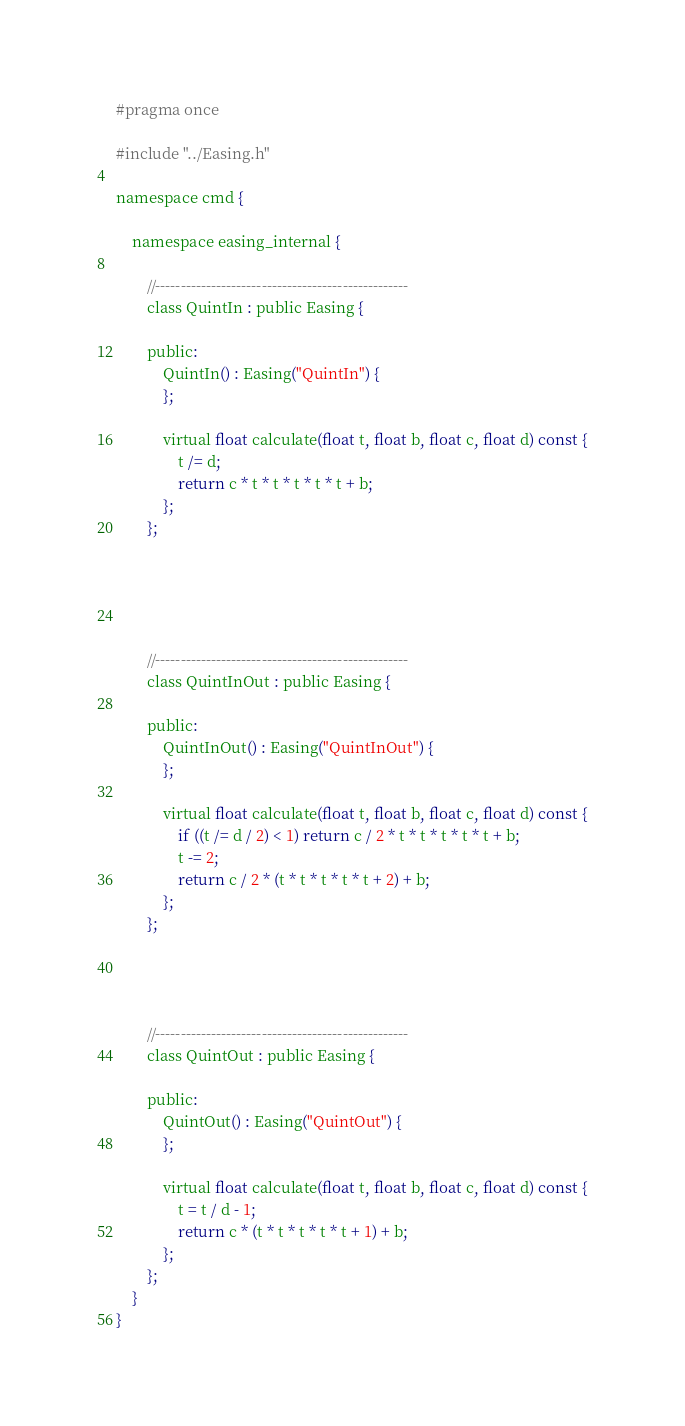Convert code to text. <code><loc_0><loc_0><loc_500><loc_500><_C_>#pragma once

#include "../Easing.h"

namespace cmd {

	namespace easing_internal {

		//--------------------------------------------------
		class QuintIn : public Easing {

		public:
			QuintIn() : Easing("QuintIn") {
			};

			virtual float calculate(float t, float b, float c, float d) const {
				t /= d;
				return c * t * t * t * t * t + b;
			};
		};





		//--------------------------------------------------
		class QuintInOut : public Easing {

		public:
			QuintInOut() : Easing("QuintInOut") {
			};

			virtual float calculate(float t, float b, float c, float d) const {
				if ((t /= d / 2) < 1) return c / 2 * t * t * t * t * t + b;
				t -= 2;
				return c / 2 * (t * t * t * t * t + 2) + b;
			};
		};




		//--------------------------------------------------
		class QuintOut : public Easing {

		public:
			QuintOut() : Easing("QuintOut") {
			};

			virtual float calculate(float t, float b, float c, float d) const {
				t = t / d - 1;
				return c * (t * t * t * t * t + 1) + b;
			};
		};
	}
}




</code> 